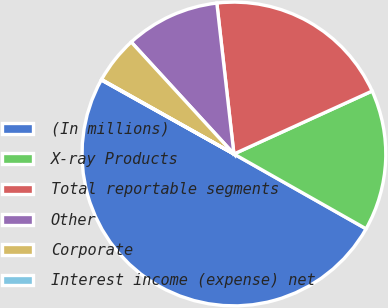Convert chart to OTSL. <chart><loc_0><loc_0><loc_500><loc_500><pie_chart><fcel>(In millions)<fcel>X-ray Products<fcel>Total reportable segments<fcel>Other<fcel>Corporate<fcel>Interest income (expense) net<nl><fcel>49.9%<fcel>15.0%<fcel>19.99%<fcel>10.02%<fcel>5.03%<fcel>0.05%<nl></chart> 